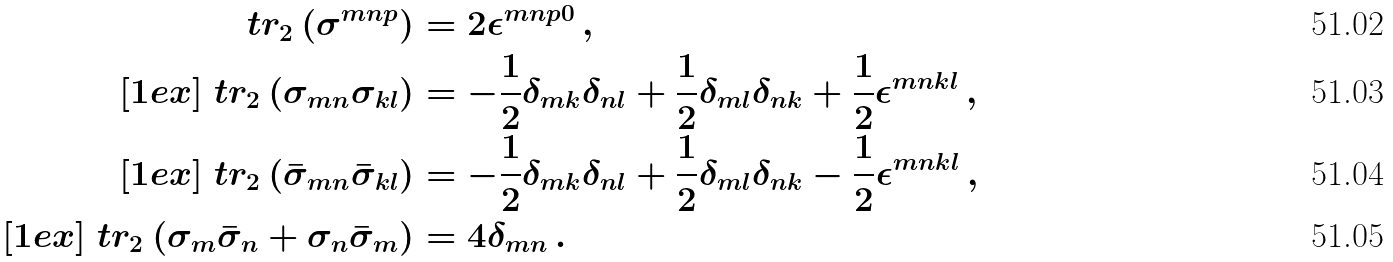<formula> <loc_0><loc_0><loc_500><loc_500>\ t r _ { 2 } \left ( \sigma ^ { m n p } \right ) & = 2 \epsilon ^ { m n p 0 } \, , \\ [ 1 e x ] \ t r _ { 2 } \left ( \sigma _ { m n } \sigma _ { k l } \right ) & = - \frac { 1 } { 2 } \delta _ { m k } \delta _ { n l } + \frac { 1 } { 2 } \delta _ { m l } \delta _ { n k } + \frac { 1 } { 2 } \epsilon ^ { m n k l } \, , \\ [ 1 e x ] \ t r _ { 2 } \left ( \bar { \sigma } _ { m n } \bar { \sigma } _ { k l } \right ) & = - \frac { 1 } { 2 } \delta _ { m k } \delta _ { n l } + \frac { 1 } { 2 } \delta _ { m l } \delta _ { n k } - \frac { 1 } { 2 } \epsilon ^ { m n k l } \, , \\ [ 1 e x ] \ t r _ { 2 } \left ( \sigma _ { m } \bar { \sigma } _ { n } + \sigma _ { n } \bar { \sigma } _ { m } \right ) & = 4 \delta _ { m n } \, .</formula> 